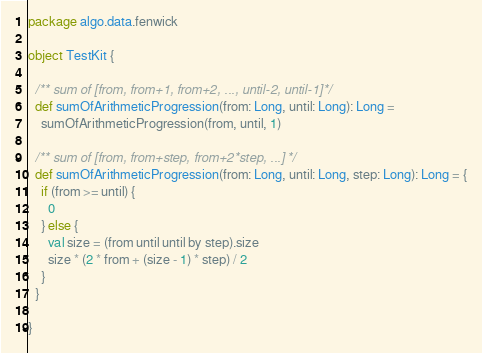Convert code to text. <code><loc_0><loc_0><loc_500><loc_500><_Scala_>package algo.data.fenwick

object TestKit {

  /** sum of [from, from+1, from+2, ..., until-2, until-1] */
  def sumOfArithmeticProgression(from: Long, until: Long): Long =
    sumOfArithmeticProgression(from, until, 1)

  /** sum of [from, from+step, from+2*step, ...] */
  def sumOfArithmeticProgression(from: Long, until: Long, step: Long): Long = {
    if (from >= until) {
      0
    } else {
      val size = (from until until by step).size
      size * (2 * from + (size - 1) * step) / 2
    }
  }

}
</code> 